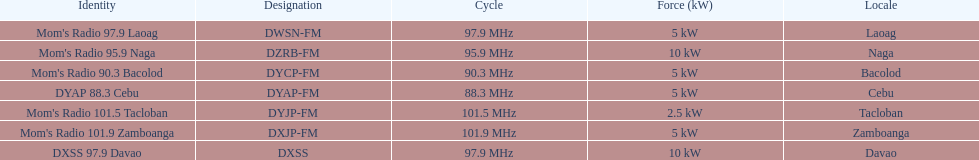What is the radio with the most mhz? Mom's Radio 101.9 Zamboanga. 